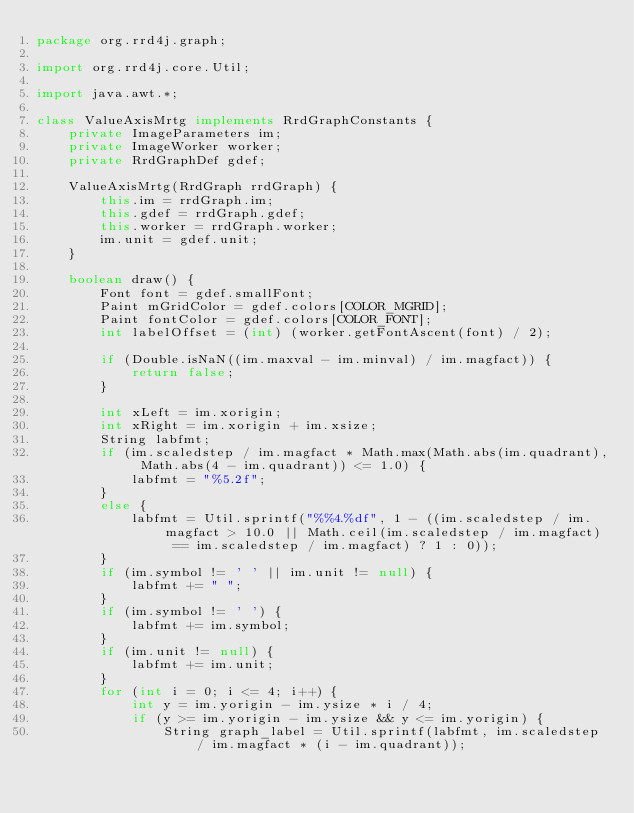<code> <loc_0><loc_0><loc_500><loc_500><_Java_>package org.rrd4j.graph;

import org.rrd4j.core.Util;

import java.awt.*;

class ValueAxisMrtg implements RrdGraphConstants {
    private ImageParameters im;
    private ImageWorker worker;
    private RrdGraphDef gdef;

    ValueAxisMrtg(RrdGraph rrdGraph) {
        this.im = rrdGraph.im;
        this.gdef = rrdGraph.gdef;
        this.worker = rrdGraph.worker;
        im.unit = gdef.unit;
    }

    boolean draw() {
        Font font = gdef.smallFont;
        Paint mGridColor = gdef.colors[COLOR_MGRID];
        Paint fontColor = gdef.colors[COLOR_FONT];
        int labelOffset = (int) (worker.getFontAscent(font) / 2);

        if (Double.isNaN((im.maxval - im.minval) / im.magfact)) {
            return false;
        }

        int xLeft = im.xorigin;
        int xRight = im.xorigin + im.xsize;
        String labfmt;
        if (im.scaledstep / im.magfact * Math.max(Math.abs(im.quadrant), Math.abs(4 - im.quadrant)) <= 1.0) {
            labfmt = "%5.2f";
        }
        else {
            labfmt = Util.sprintf("%%4.%df", 1 - ((im.scaledstep / im.magfact > 10.0 || Math.ceil(im.scaledstep / im.magfact) == im.scaledstep / im.magfact) ? 1 : 0));
        }
        if (im.symbol != ' ' || im.unit != null) {
            labfmt += " ";
        }
        if (im.symbol != ' ') {
            labfmt += im.symbol;
        }
        if (im.unit != null) {
            labfmt += im.unit;
        }
        for (int i = 0; i <= 4; i++) {
            int y = im.yorigin - im.ysize * i / 4;
            if (y >= im.yorigin - im.ysize && y <= im.yorigin) {
                String graph_label = Util.sprintf(labfmt, im.scaledstep / im.magfact * (i - im.quadrant));</code> 